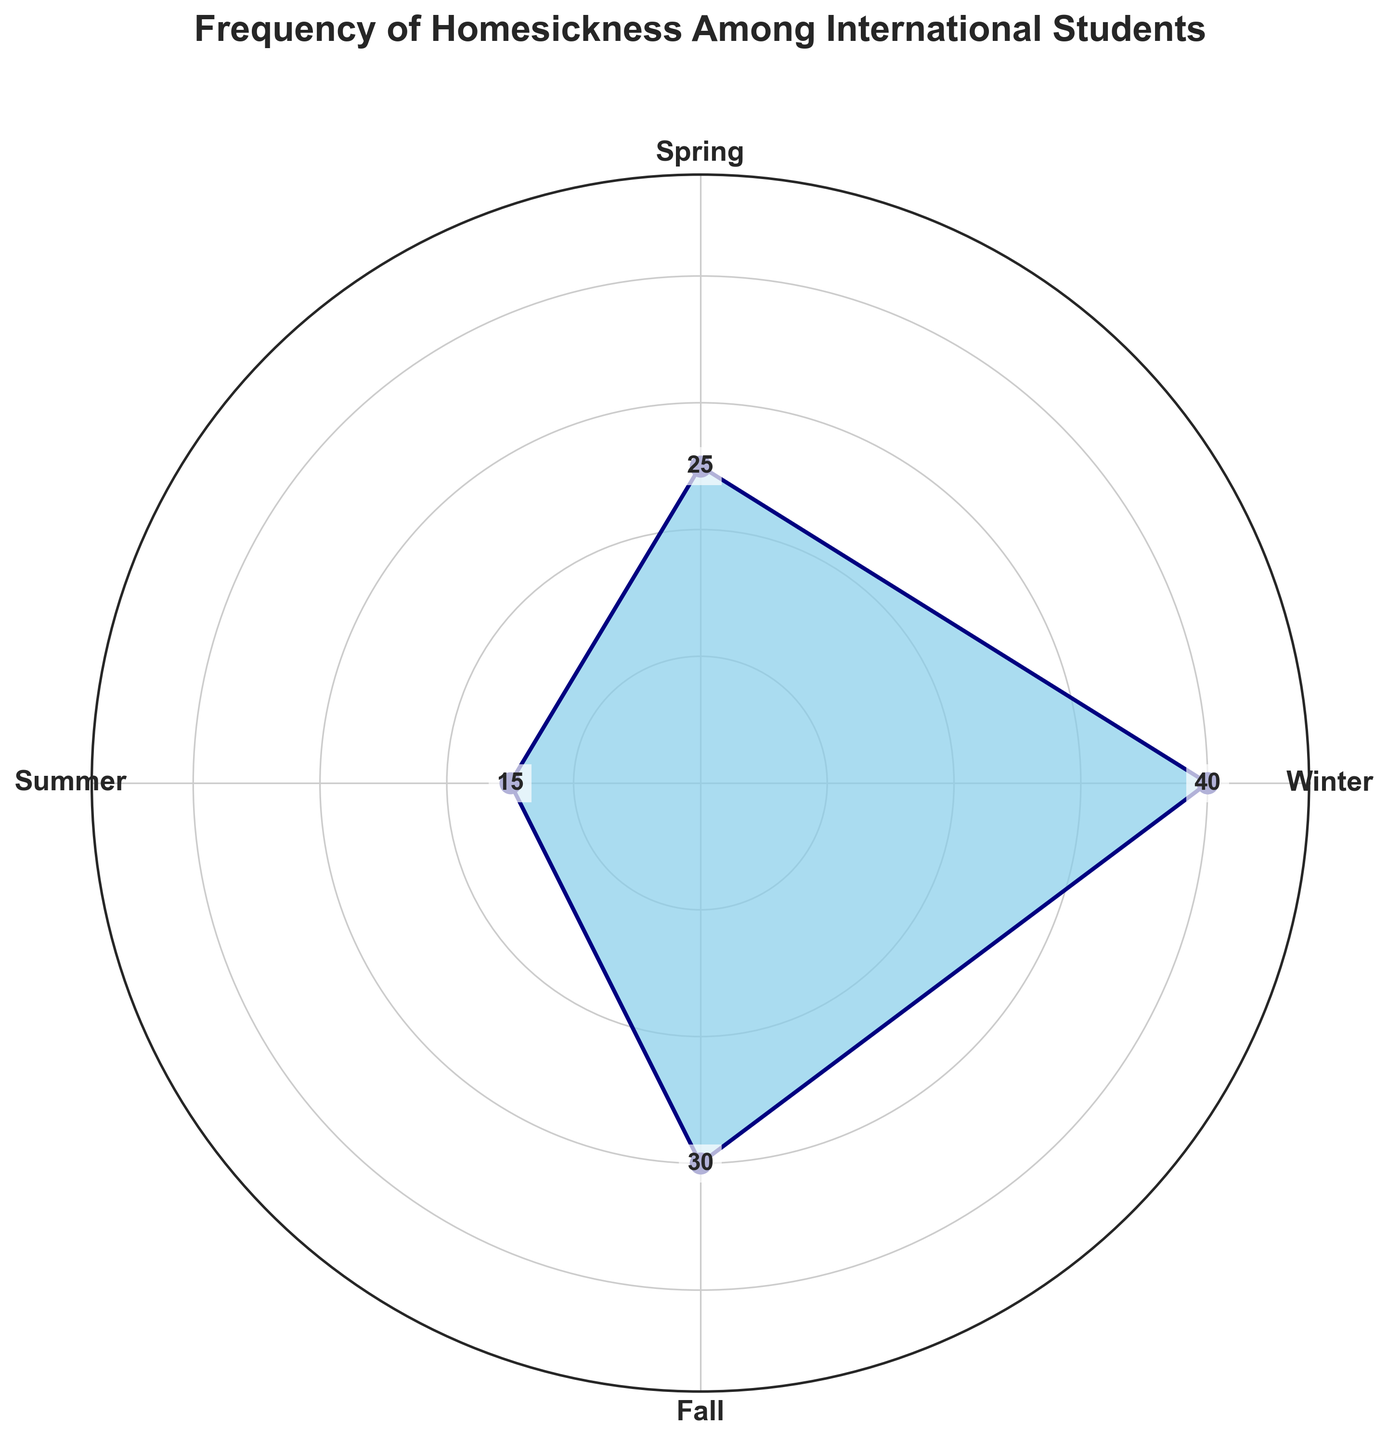What is the title of the plot? The title is generally placed at the top of the plot in a larger and bolder font for easy identification.
Answer: Frequency of Homesickness Among International Students What season shows the highest frequency of homesickness? Look for the season where the blue area extends the furthest from the center, indicating the highest value.
Answer: Winter What is the frequency of homesickness in the fall season? Identify the section labeled "Fall" and read the corresponding number displayed near the periphery of the plot.
Answer: 30 During which season do students feel the least homesick? Compare the lengths of the segments for all seasons and identify the shortest one.
Answer: Summer By how much does the frequency of homesickness in spring exceed that in summer? Subtract the value for summer from the value for spring; i.e., 25 - 15.
Answer: 10 What is the average frequency of homesickness across all seasons? Sum the homesickness frequencies for all four seasons and divide by the number of seasons: (40 + 25 + 15 + 30) / 4.
Answer: 27.5 Which seasons have a homesickness frequency higher than 20? Identify and list the seasons with frequency values greater than 20 by checking each segment on the plot.
Answer: Winter, Spring, Fall Is the homesickness frequency in winter more than double the frequency in summer? Double the summer value and compare it with the winter value: 15 * 2 = 30, then see if 40 > 30.
Answer: Yes In terms of homesickness frequency, how does fall compare with spring? Subtract the frequency in spring from the frequency in fall: 30 - 25.
Answer: Fall is 5 higher By how much does the frequency of homesickness in winter exceed the average frequency of homesickness? First, find the average frequency (27.5), then subtract it from the winter value: 40 - 27.5.
Answer: 12.5 